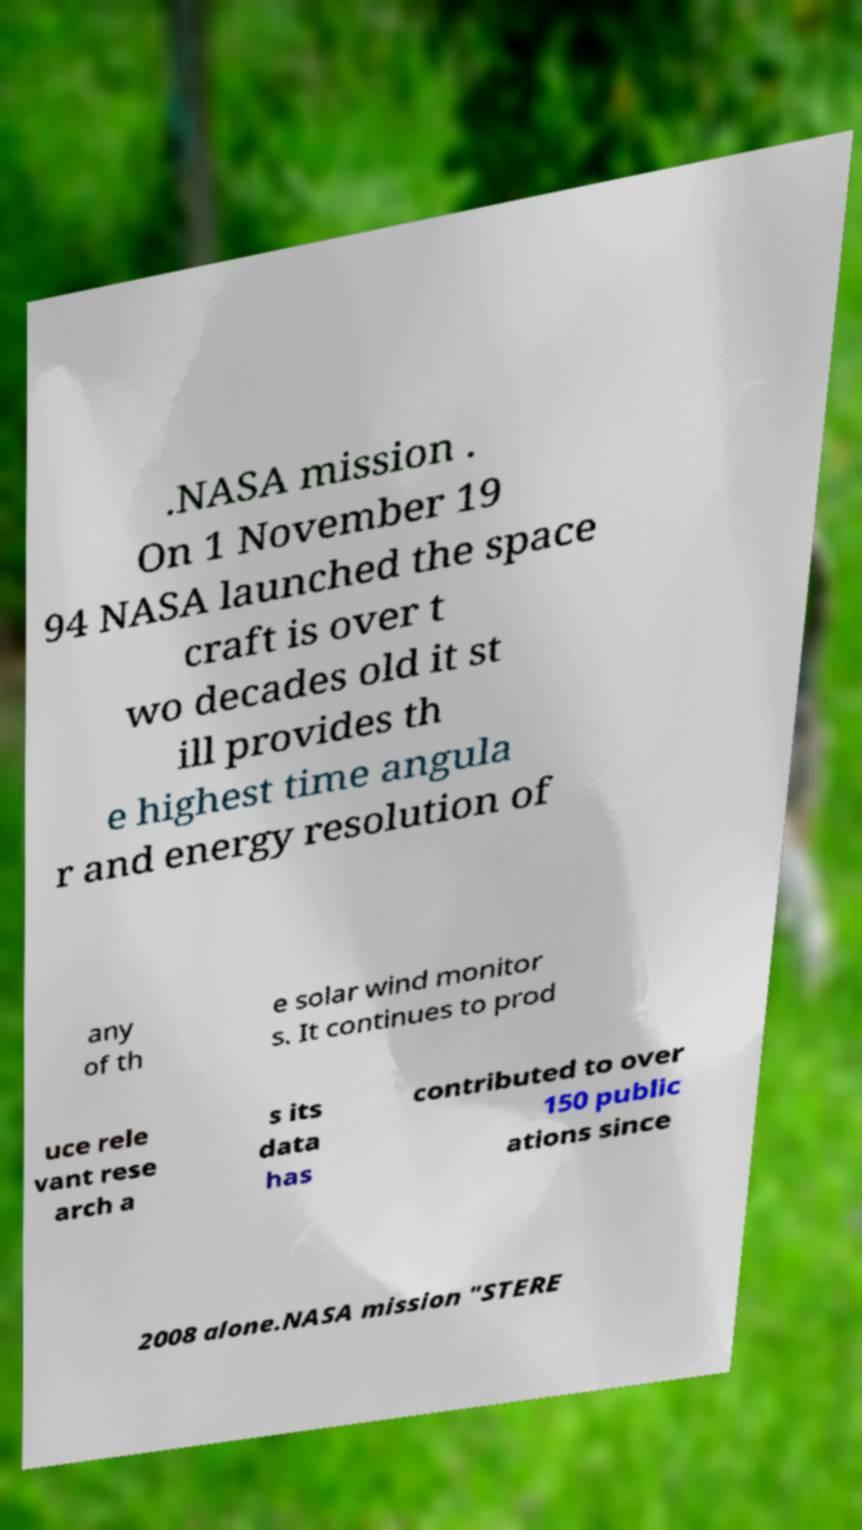What messages or text are displayed in this image? I need them in a readable, typed format. .NASA mission . On 1 November 19 94 NASA launched the space craft is over t wo decades old it st ill provides th e highest time angula r and energy resolution of any of th e solar wind monitor s. It continues to prod uce rele vant rese arch a s its data has contributed to over 150 public ations since 2008 alone.NASA mission "STERE 